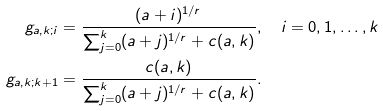<formula> <loc_0><loc_0><loc_500><loc_500>g _ { a , k ; i } & = \frac { ( a + i ) ^ { 1 / r } } { \sum _ { j = 0 } ^ { k } ( a + j ) ^ { 1 / r } + c ( a , k ) } , \quad i = 0 , 1 , \dots , k \\ g _ { a , k ; k + 1 } & = \frac { c ( a , k ) } { \sum _ { j = 0 } ^ { k } ( a + j ) ^ { 1 / r } + c ( a , k ) } .</formula> 